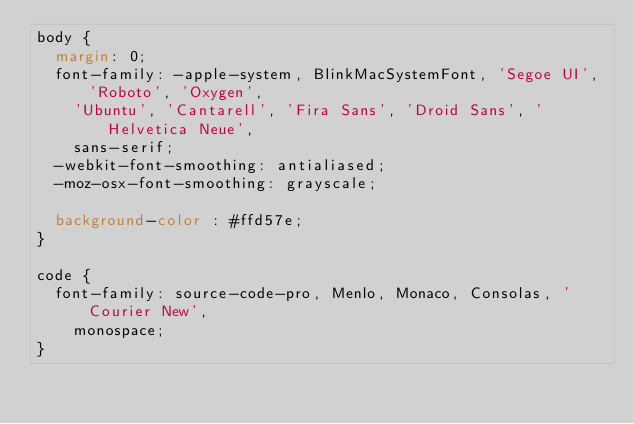Convert code to text. <code><loc_0><loc_0><loc_500><loc_500><_CSS_>body {
  margin: 0;
  font-family: -apple-system, BlinkMacSystemFont, 'Segoe UI', 'Roboto', 'Oxygen',
    'Ubuntu', 'Cantarell', 'Fira Sans', 'Droid Sans', 'Helvetica Neue',
    sans-serif;
  -webkit-font-smoothing: antialiased;
  -moz-osx-font-smoothing: grayscale;

  background-color : #ffd57e;
}

code {
  font-family: source-code-pro, Menlo, Monaco, Consolas, 'Courier New',
    monospace;
}
</code> 